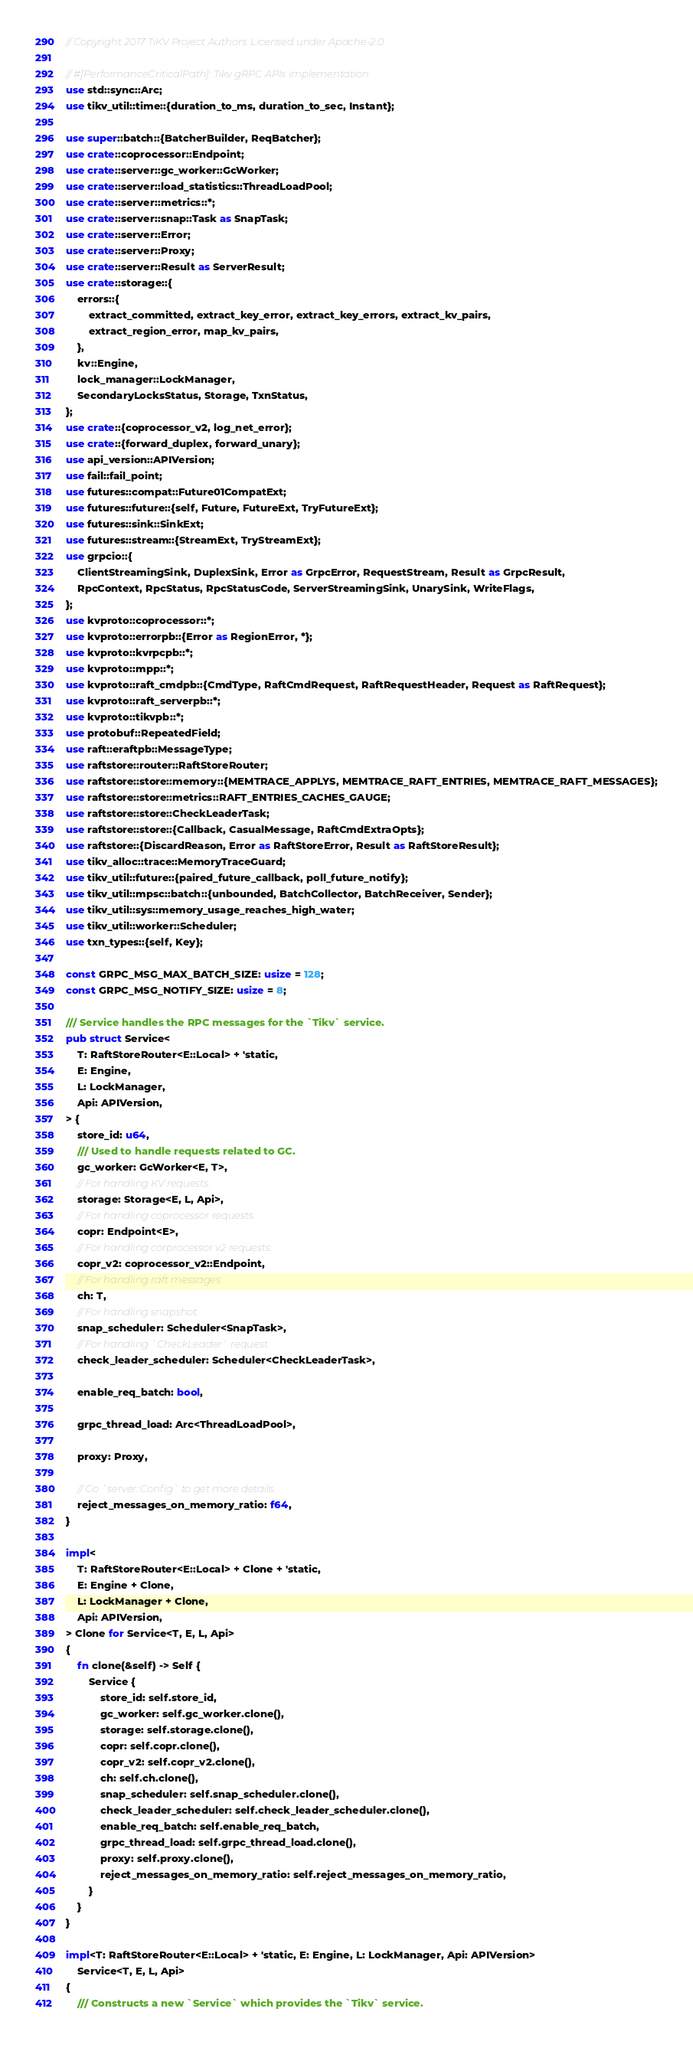<code> <loc_0><loc_0><loc_500><loc_500><_Rust_>// Copyright 2017 TiKV Project Authors. Licensed under Apache-2.0.

// #[PerformanceCriticalPath]: Tikv gRPC APIs implementation
use std::sync::Arc;
use tikv_util::time::{duration_to_ms, duration_to_sec, Instant};

use super::batch::{BatcherBuilder, ReqBatcher};
use crate::coprocessor::Endpoint;
use crate::server::gc_worker::GcWorker;
use crate::server::load_statistics::ThreadLoadPool;
use crate::server::metrics::*;
use crate::server::snap::Task as SnapTask;
use crate::server::Error;
use crate::server::Proxy;
use crate::server::Result as ServerResult;
use crate::storage::{
    errors::{
        extract_committed, extract_key_error, extract_key_errors, extract_kv_pairs,
        extract_region_error, map_kv_pairs,
    },
    kv::Engine,
    lock_manager::LockManager,
    SecondaryLocksStatus, Storage, TxnStatus,
};
use crate::{coprocessor_v2, log_net_error};
use crate::{forward_duplex, forward_unary};
use api_version::APIVersion;
use fail::fail_point;
use futures::compat::Future01CompatExt;
use futures::future::{self, Future, FutureExt, TryFutureExt};
use futures::sink::SinkExt;
use futures::stream::{StreamExt, TryStreamExt};
use grpcio::{
    ClientStreamingSink, DuplexSink, Error as GrpcError, RequestStream, Result as GrpcResult,
    RpcContext, RpcStatus, RpcStatusCode, ServerStreamingSink, UnarySink, WriteFlags,
};
use kvproto::coprocessor::*;
use kvproto::errorpb::{Error as RegionError, *};
use kvproto::kvrpcpb::*;
use kvproto::mpp::*;
use kvproto::raft_cmdpb::{CmdType, RaftCmdRequest, RaftRequestHeader, Request as RaftRequest};
use kvproto::raft_serverpb::*;
use kvproto::tikvpb::*;
use protobuf::RepeatedField;
use raft::eraftpb::MessageType;
use raftstore::router::RaftStoreRouter;
use raftstore::store::memory::{MEMTRACE_APPLYS, MEMTRACE_RAFT_ENTRIES, MEMTRACE_RAFT_MESSAGES};
use raftstore::store::metrics::RAFT_ENTRIES_CACHES_GAUGE;
use raftstore::store::CheckLeaderTask;
use raftstore::store::{Callback, CasualMessage, RaftCmdExtraOpts};
use raftstore::{DiscardReason, Error as RaftStoreError, Result as RaftStoreResult};
use tikv_alloc::trace::MemoryTraceGuard;
use tikv_util::future::{paired_future_callback, poll_future_notify};
use tikv_util::mpsc::batch::{unbounded, BatchCollector, BatchReceiver, Sender};
use tikv_util::sys::memory_usage_reaches_high_water;
use tikv_util::worker::Scheduler;
use txn_types::{self, Key};

const GRPC_MSG_MAX_BATCH_SIZE: usize = 128;
const GRPC_MSG_NOTIFY_SIZE: usize = 8;

/// Service handles the RPC messages for the `Tikv` service.
pub struct Service<
    T: RaftStoreRouter<E::Local> + 'static,
    E: Engine,
    L: LockManager,
    Api: APIVersion,
> {
    store_id: u64,
    /// Used to handle requests related to GC.
    gc_worker: GcWorker<E, T>,
    // For handling KV requests.
    storage: Storage<E, L, Api>,
    // For handling coprocessor requests.
    copr: Endpoint<E>,
    // For handling corprocessor v2 requests.
    copr_v2: coprocessor_v2::Endpoint,
    // For handling raft messages.
    ch: T,
    // For handling snapshot.
    snap_scheduler: Scheduler<SnapTask>,
    // For handling `CheckLeader` request.
    check_leader_scheduler: Scheduler<CheckLeaderTask>,

    enable_req_batch: bool,

    grpc_thread_load: Arc<ThreadLoadPool>,

    proxy: Proxy,

    // Go `server::Config` to get more details.
    reject_messages_on_memory_ratio: f64,
}

impl<
    T: RaftStoreRouter<E::Local> + Clone + 'static,
    E: Engine + Clone,
    L: LockManager + Clone,
    Api: APIVersion,
> Clone for Service<T, E, L, Api>
{
    fn clone(&self) -> Self {
        Service {
            store_id: self.store_id,
            gc_worker: self.gc_worker.clone(),
            storage: self.storage.clone(),
            copr: self.copr.clone(),
            copr_v2: self.copr_v2.clone(),
            ch: self.ch.clone(),
            snap_scheduler: self.snap_scheduler.clone(),
            check_leader_scheduler: self.check_leader_scheduler.clone(),
            enable_req_batch: self.enable_req_batch,
            grpc_thread_load: self.grpc_thread_load.clone(),
            proxy: self.proxy.clone(),
            reject_messages_on_memory_ratio: self.reject_messages_on_memory_ratio,
        }
    }
}

impl<T: RaftStoreRouter<E::Local> + 'static, E: Engine, L: LockManager, Api: APIVersion>
    Service<T, E, L, Api>
{
    /// Constructs a new `Service` which provides the `Tikv` service.</code> 